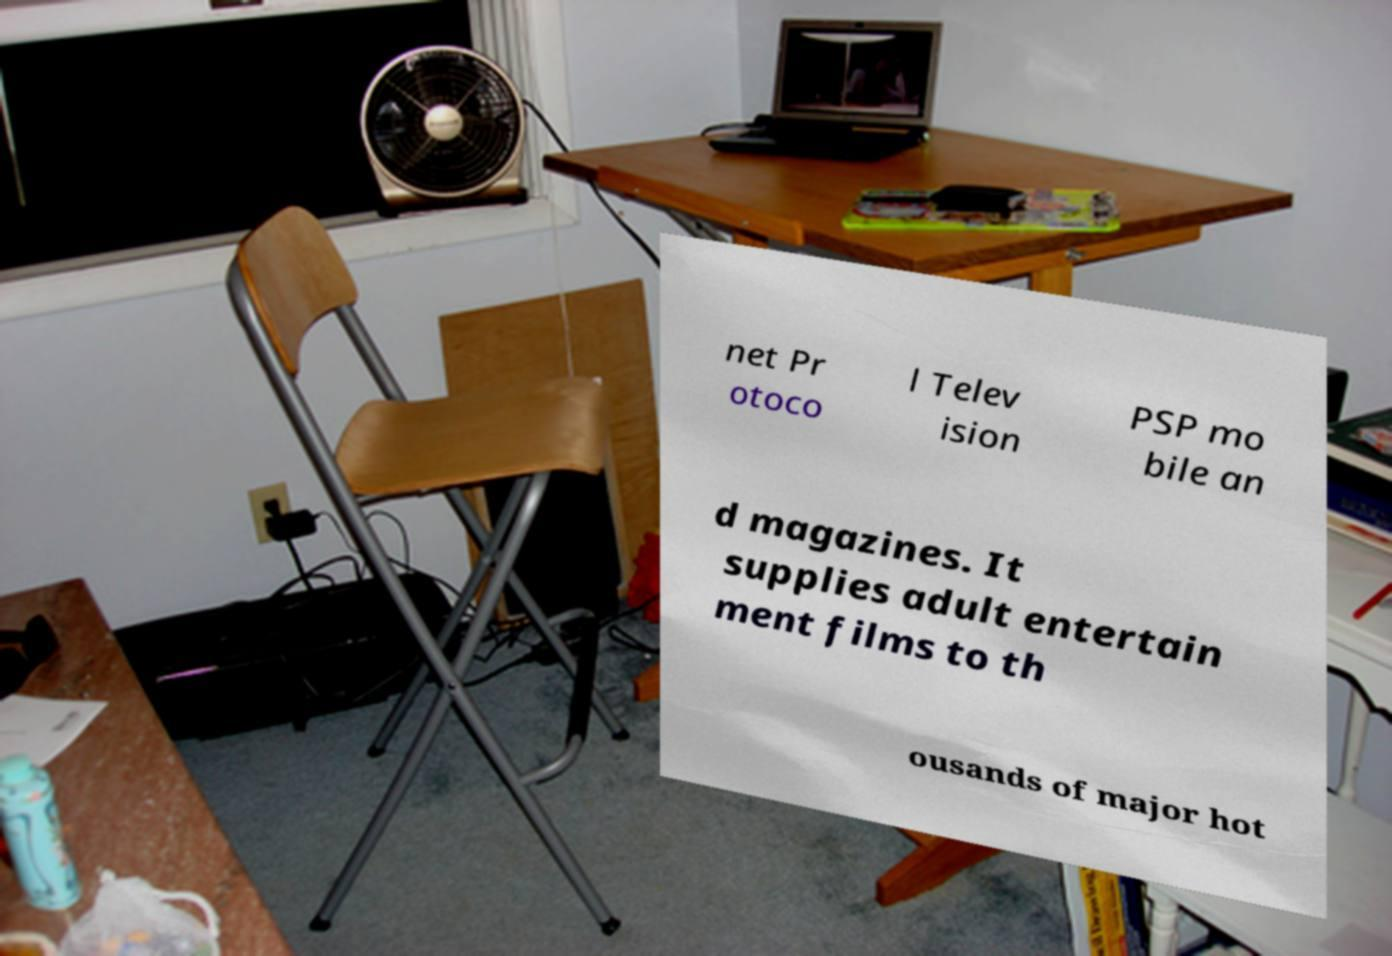Could you assist in decoding the text presented in this image and type it out clearly? net Pr otoco l Telev ision PSP mo bile an d magazines. It supplies adult entertain ment films to th ousands of major hot 